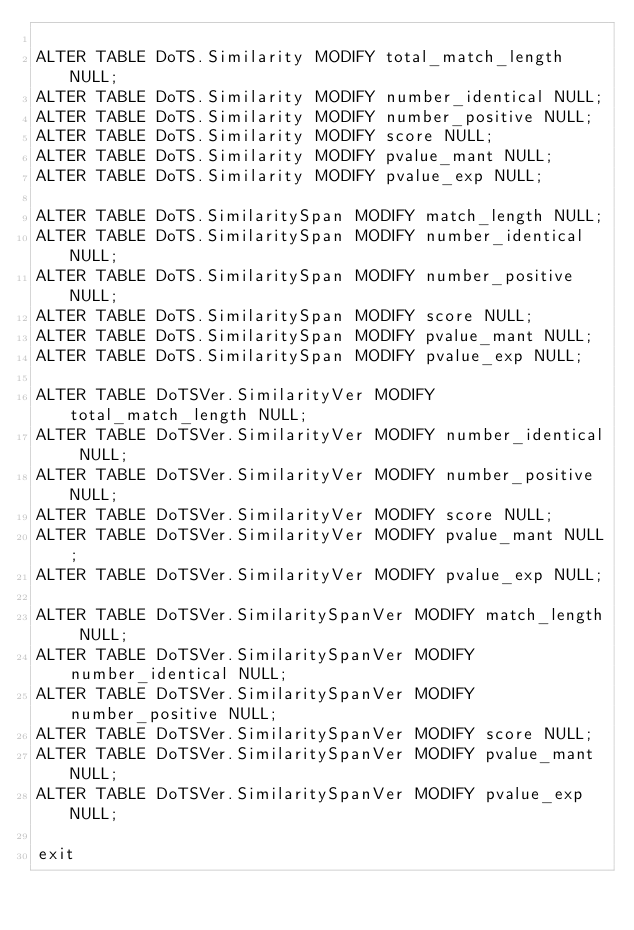<code> <loc_0><loc_0><loc_500><loc_500><_SQL_>
ALTER TABLE DoTS.Similarity MODIFY total_match_length NULL;
ALTER TABLE DoTS.Similarity MODIFY number_identical NULL;
ALTER TABLE DoTS.Similarity MODIFY number_positive NULL;
ALTER TABLE DoTS.Similarity MODIFY score NULL;
ALTER TABLE DoTS.Similarity MODIFY pvalue_mant NULL;
ALTER TABLE DoTS.Similarity MODIFY pvalue_exp NULL;

ALTER TABLE DoTS.SimilaritySpan MODIFY match_length NULL;
ALTER TABLE DoTS.SimilaritySpan MODIFY number_identical NULL;
ALTER TABLE DoTS.SimilaritySpan MODIFY number_positive NULL;
ALTER TABLE DoTS.SimilaritySpan MODIFY score NULL;
ALTER TABLE DoTS.SimilaritySpan MODIFY pvalue_mant NULL;
ALTER TABLE DoTS.SimilaritySpan MODIFY pvalue_exp NULL;

ALTER TABLE DoTSVer.SimilarityVer MODIFY total_match_length NULL;
ALTER TABLE DoTSVer.SimilarityVer MODIFY number_identical NULL;
ALTER TABLE DoTSVer.SimilarityVer MODIFY number_positive NULL;
ALTER TABLE DoTSVer.SimilarityVer MODIFY score NULL;
ALTER TABLE DoTSVer.SimilarityVer MODIFY pvalue_mant NULL;
ALTER TABLE DoTSVer.SimilarityVer MODIFY pvalue_exp NULL;

ALTER TABLE DoTSVer.SimilaritySpanVer MODIFY match_length NULL;
ALTER TABLE DoTSVer.SimilaritySpanVer MODIFY number_identical NULL;
ALTER TABLE DoTSVer.SimilaritySpanVer MODIFY number_positive NULL;
ALTER TABLE DoTSVer.SimilaritySpanVer MODIFY score NULL;
ALTER TABLE DoTSVer.SimilaritySpanVer MODIFY pvalue_mant NULL;
ALTER TABLE DoTSVer.SimilaritySpanVer MODIFY pvalue_exp NULL;

exit
</code> 